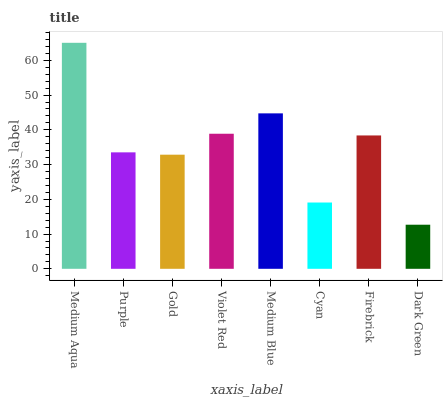Is Dark Green the minimum?
Answer yes or no. Yes. Is Medium Aqua the maximum?
Answer yes or no. Yes. Is Purple the minimum?
Answer yes or no. No. Is Purple the maximum?
Answer yes or no. No. Is Medium Aqua greater than Purple?
Answer yes or no. Yes. Is Purple less than Medium Aqua?
Answer yes or no. Yes. Is Purple greater than Medium Aqua?
Answer yes or no. No. Is Medium Aqua less than Purple?
Answer yes or no. No. Is Firebrick the high median?
Answer yes or no. Yes. Is Purple the low median?
Answer yes or no. Yes. Is Gold the high median?
Answer yes or no. No. Is Violet Red the low median?
Answer yes or no. No. 